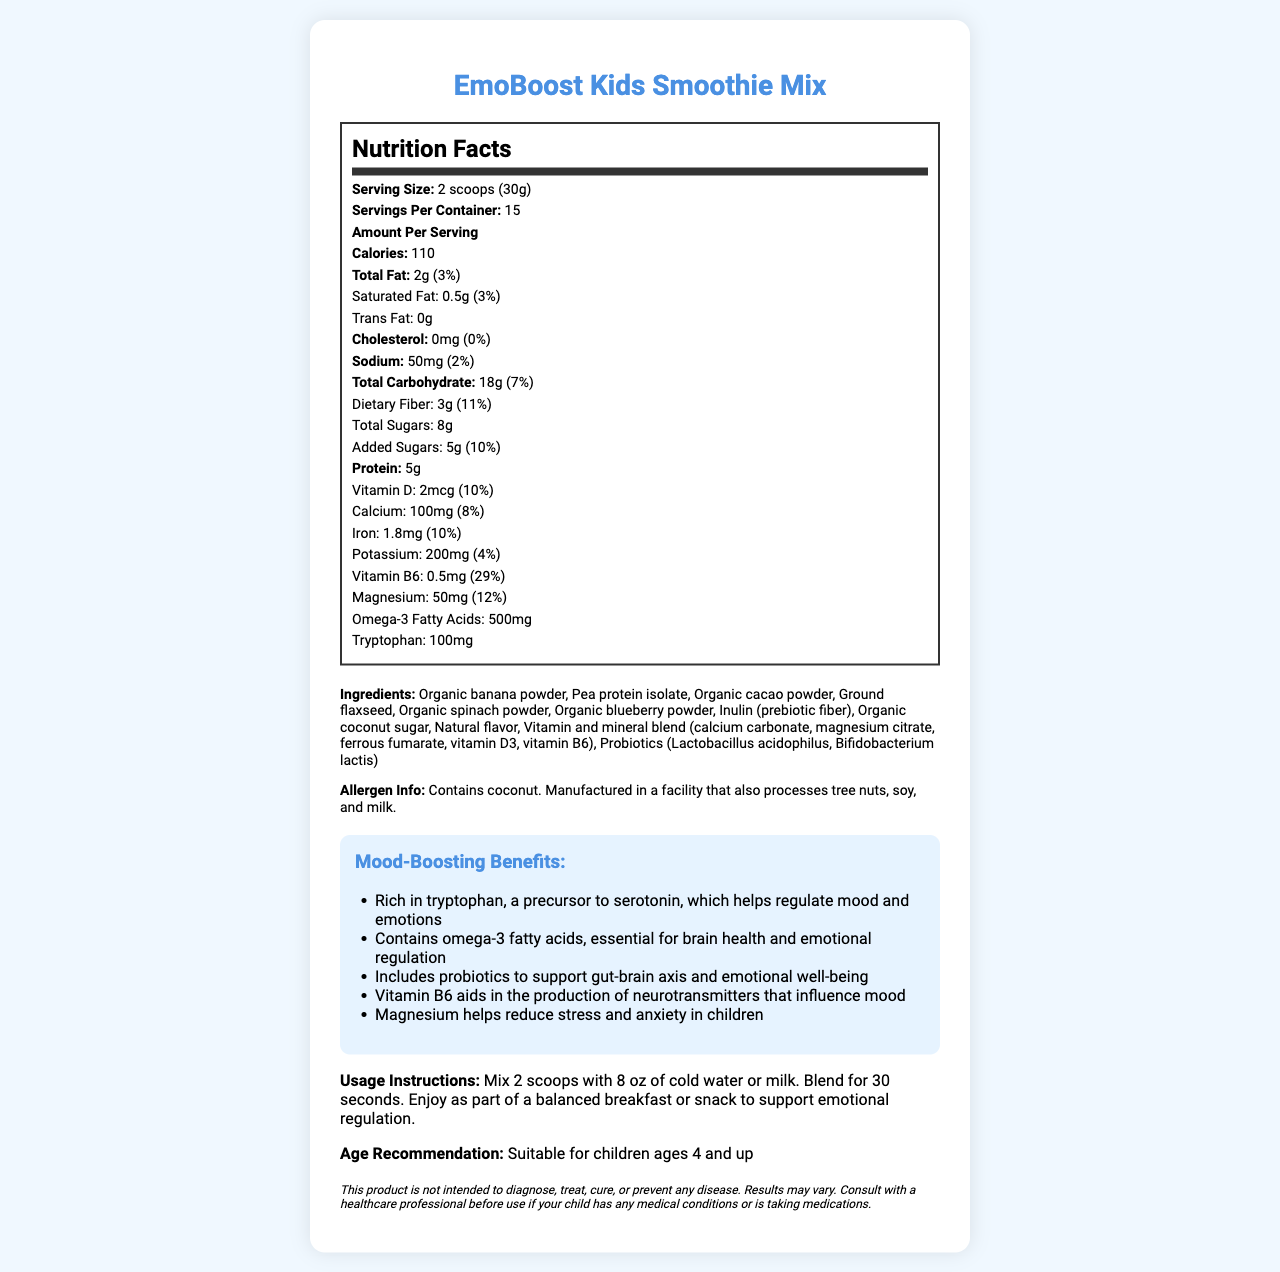what is the serving size? The serving size is mentioned at the top of the nutrition label section as "Serving Size: 2 scoops (30g)".
Answer: 2 scoops (30g) how many calories are there per serving? The number of calories per serving is listed as "Calories: 110" in the nutrition label.
Answer: 110 how much protein is provided per serving? The amount of protein per serving is listed under the nutrition label as "Protein: 5g".
Answer: 5g how much vitamin D is in one serving? Vitamin D content per serving is listed as "Vitamin D: 2mcg (10%)" in the nutrition label.
Answer: 2mcg or 10% Daily Value what are the mood-boosting benefits of this product? The benefits listed are: "Rich in tryptophan, a precursor to serotonin, which helps regulate mood and emotions, Contains omega-3 fatty acids, essential for brain health and emotional regulation, Includes probiotics to support gut-brain axis and emotional well-being, Vitamin B6 aids in the production of neurotransmitters that influence mood, Magnesium helps reduce stress and anxiety in children."
Answer: Rich in tryptophan, contains omega-3 fatty acids, includes probiotics, vitamin B6, magnesium what percentage of the daily value of calcium does one serving provide? The percentage of daily value for calcium is listed as "Calcium: 100mg (8%)".
Answer: 8% does this product contain any allergens? The allergen information states, "Contains coconut. Manufactured in a facility that also processes tree nuts, soy, and milk."
Answer: Yes what is the total amount of dietary fiber per serving? The amount of dietary fiber is listed as "Dietary Fiber: 3g (11%)" in the nutrition label.
Answer: 3g or 11% Daily Value what is the source of protein in this product? Pea protein isolate is listed as one of the ingredients in the document.
Answer: Pea protein isolate what is the recommended age for consuming this product? The age recommendation is clearly stated as "Suitable for children ages 4 and up".
Answer: Suitable for children ages 4 and up how much tryptophan is in one serving of the smoothie mix? The amount of tryptophan per serving is listed under the nutrition label as "Tryptophan: 100mg".
Answer: 100mg how many servings are in one container? The number of servings per container is listed as "Servings Per Container: 15".
Answer: 15 how much sugar is added per serving? The amount of added sugars is listed in the nutrition label as "Added Sugars: 5g (10%)".
Answer: 5g or 10% Daily Value which nutrient contributes the highest daily value percentage per serving? A. Vitamin D B. Magnesium C. Vitamin B6 Vitamin B6 has the highest daily value percentage per serving at 29%, compared to Vitamin D (10%) and Magnesium (12%).
Answer: C. Vitamin B6 which of the following ingredients is not listed in the smoothie mix? A. Organic spinach powder B. Organic blueberry powder C. Organic apple powder D. Pea protein isolate The ingredients listed include organic spinach powder, organic blueberry powder, and pea protein isolate, but not organic apple powder.
Answer: C. Organic apple powder is there any cholesterol in one serving of this product? The cholesterol amount is listed as "0mg (0%)" in the nutrition label.
Answer: No what are the usage instructions for this smoothie mix? The usage instructions are clearly stated under the usage instructions section.
Answer: Mix 2 scoops with 8 oz of cold water or milk. Blend for 30 seconds. Enjoy as part of a balanced breakfast or snack to support emotional regulation. summarize the main nutritional and mood-boosting benefits of EmoBoost Kids Smoothie Mix. The document outlines the product name, nutritional facts, ingredients, allergen information, mood-boosting benefits, usage instructions, and age recommendation. The focus is on providing essential nutrients and components that aid in emotional well-being.
Answer: EmoBoost Kids Smoothie Mix provides a balanced nutritional profile with calories, fats, carbohydrates, protein, vitamins, and minerals, specifically designed to support children's emotional regulation with ingredients like tryptophan, omega-3 fatty acids, vitamin B6, magnesium, and probiotics. how effective is this product in treating anxiety in children? The document includes a disclaimer stating, "This product is not intended to diagnose, treat, cure, or prevent any disease. Results may vary." Thus, its effectiveness in treating anxiety cannot be determined based solely on the document's information.
Answer: Cannot be determined 